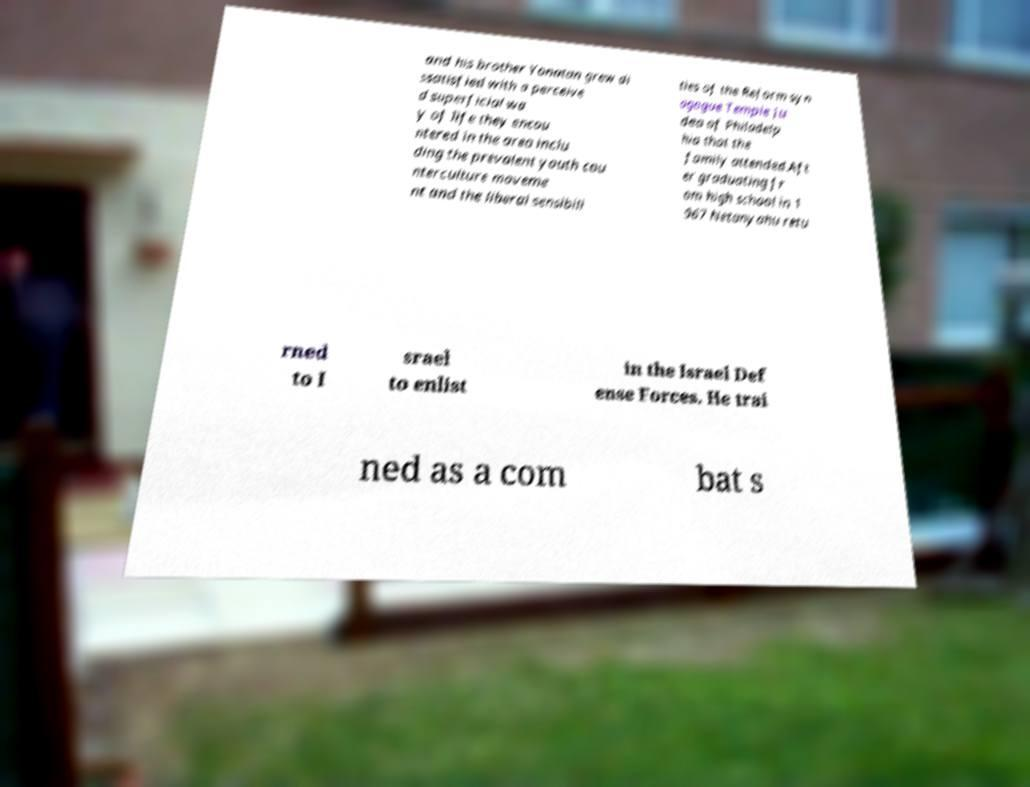Could you assist in decoding the text presented in this image and type it out clearly? and his brother Yonatan grew di ssatisfied with a perceive d superficial wa y of life they encou ntered in the area inclu ding the prevalent youth cou nterculture moveme nt and the liberal sensibili ties of the Reform syn agogue Temple Ju dea of Philadelp hia that the family attended.Aft er graduating fr om high school in 1 967 Netanyahu retu rned to I srael to enlist in the Israel Def ense Forces. He trai ned as a com bat s 